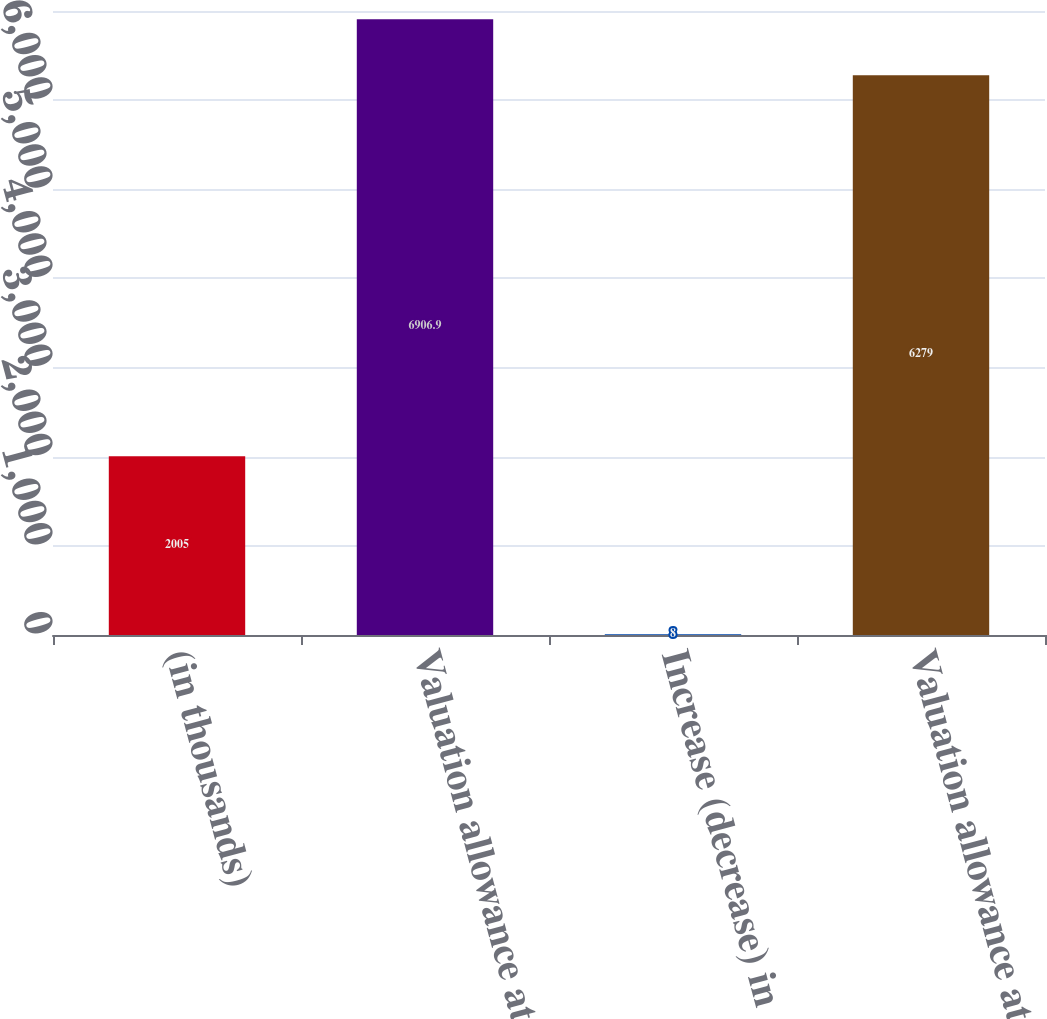<chart> <loc_0><loc_0><loc_500><loc_500><bar_chart><fcel>(in thousands)<fcel>Valuation allowance at<fcel>Increase (decrease) in<fcel>Valuation allowance at end of<nl><fcel>2005<fcel>6906.9<fcel>8<fcel>6279<nl></chart> 